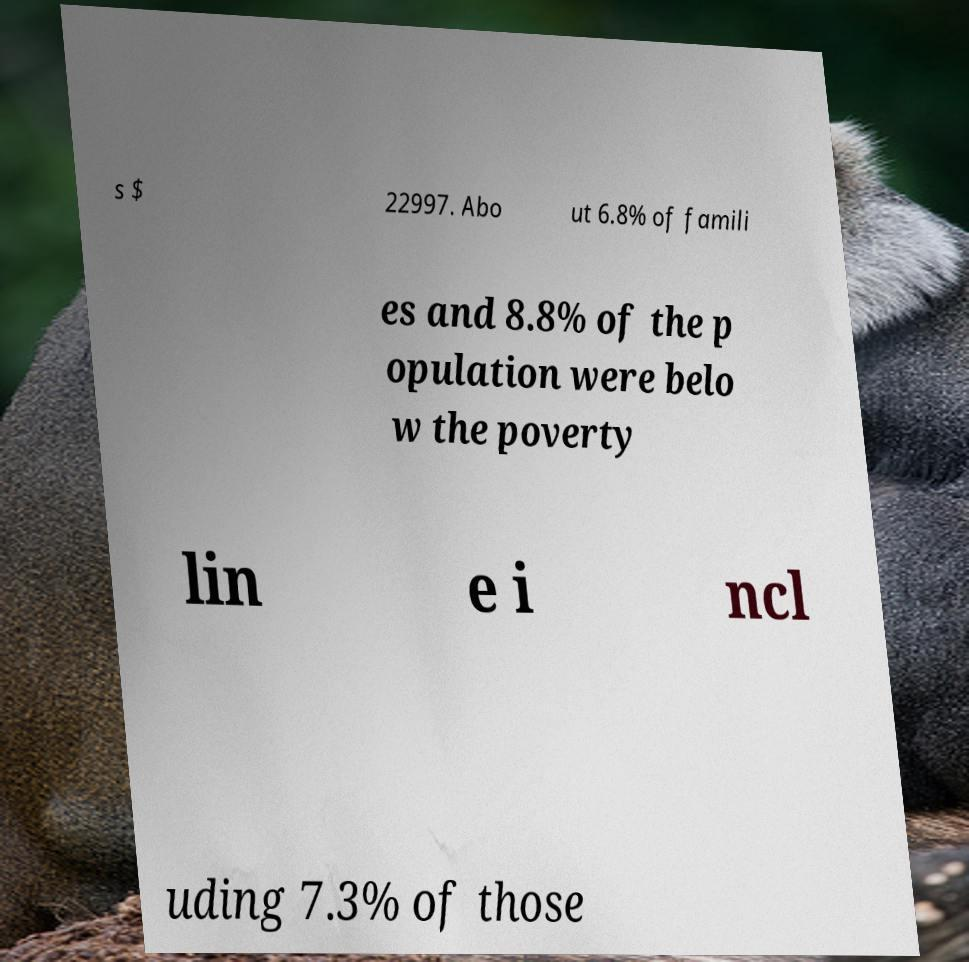There's text embedded in this image that I need extracted. Can you transcribe it verbatim? s $ 22997. Abo ut 6.8% of famili es and 8.8% of the p opulation were belo w the poverty lin e i ncl uding 7.3% of those 